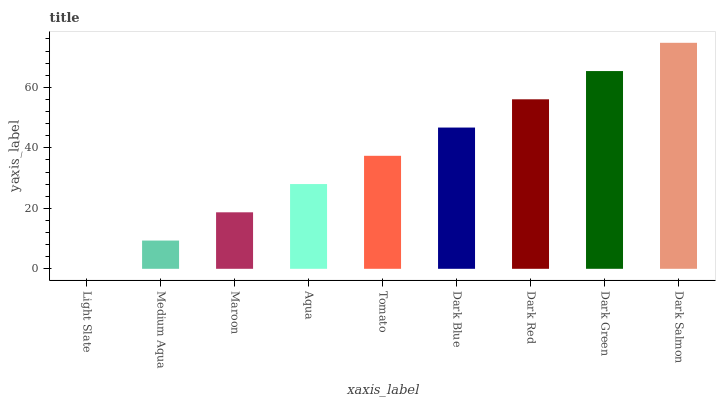Is Medium Aqua the minimum?
Answer yes or no. No. Is Medium Aqua the maximum?
Answer yes or no. No. Is Medium Aqua greater than Light Slate?
Answer yes or no. Yes. Is Light Slate less than Medium Aqua?
Answer yes or no. Yes. Is Light Slate greater than Medium Aqua?
Answer yes or no. No. Is Medium Aqua less than Light Slate?
Answer yes or no. No. Is Tomato the high median?
Answer yes or no. Yes. Is Tomato the low median?
Answer yes or no. Yes. Is Light Slate the high median?
Answer yes or no. No. Is Dark Red the low median?
Answer yes or no. No. 